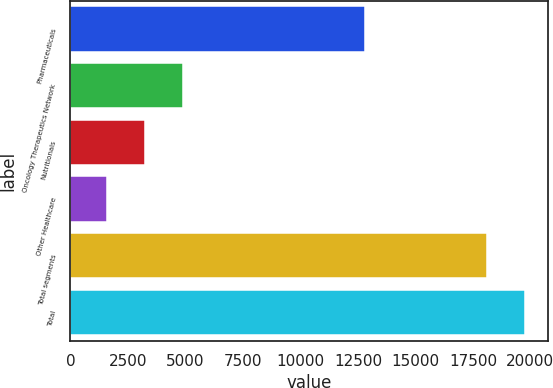Convert chart to OTSL. <chart><loc_0><loc_0><loc_500><loc_500><bar_chart><fcel>Pharmaceuticals<fcel>Oncology Therapeutics Network<fcel>Nutritionals<fcel>Other Healthcare<fcel>Total segments<fcel>Total<nl><fcel>12812<fcel>4879.6<fcel>3226.3<fcel>1573<fcel>18106<fcel>19759.3<nl></chart> 